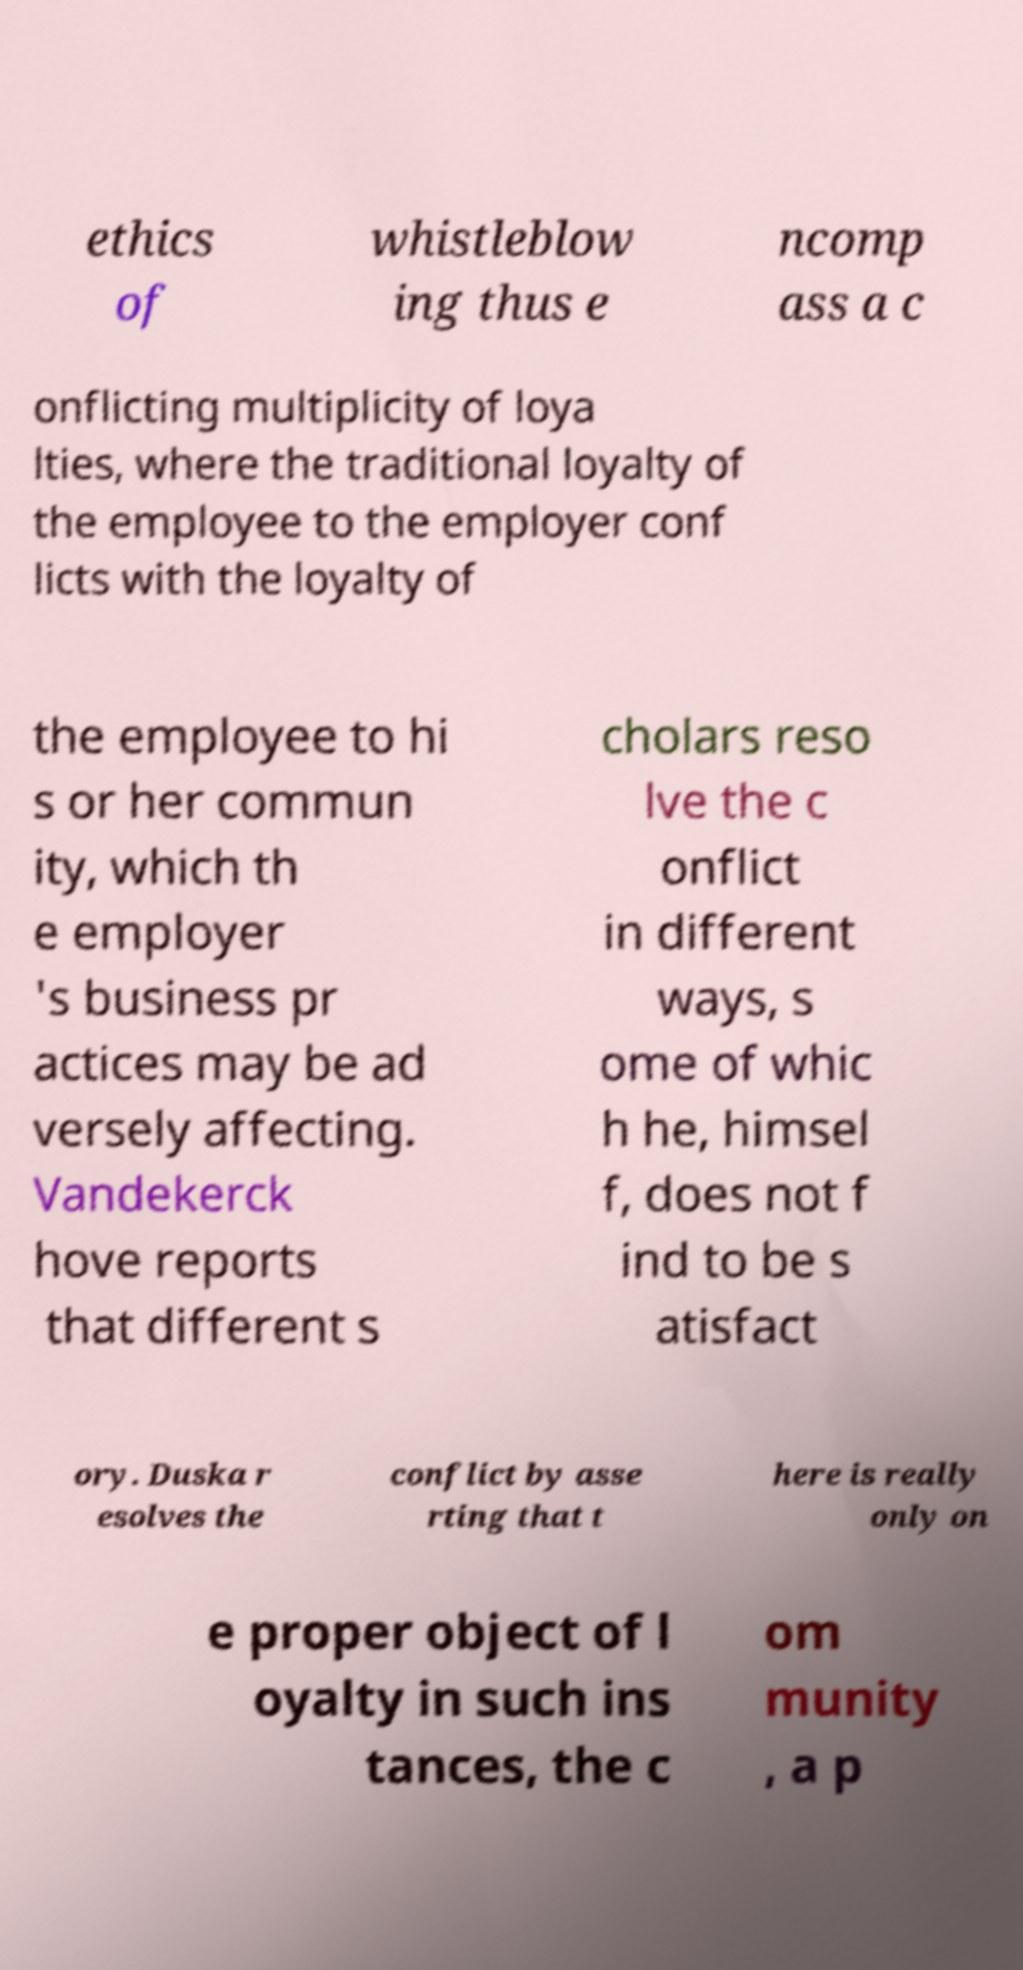Please identify and transcribe the text found in this image. ethics of whistleblow ing thus e ncomp ass a c onflicting multiplicity of loya lties, where the traditional loyalty of the employee to the employer conf licts with the loyalty of the employee to hi s or her commun ity, which th e employer 's business pr actices may be ad versely affecting. Vandekerck hove reports that different s cholars reso lve the c onflict in different ways, s ome of whic h he, himsel f, does not f ind to be s atisfact ory. Duska r esolves the conflict by asse rting that t here is really only on e proper object of l oyalty in such ins tances, the c om munity , a p 